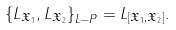Convert formula to latex. <formula><loc_0><loc_0><loc_500><loc_500>\left \{ L _ { \mathfrak { X } _ { 1 } } , L _ { \mathfrak { X } _ { 2 } } \right \} _ { L - P } = L _ { [ \mathfrak { X } _ { 1 } , \mathfrak { X } _ { 2 } ] } .</formula> 